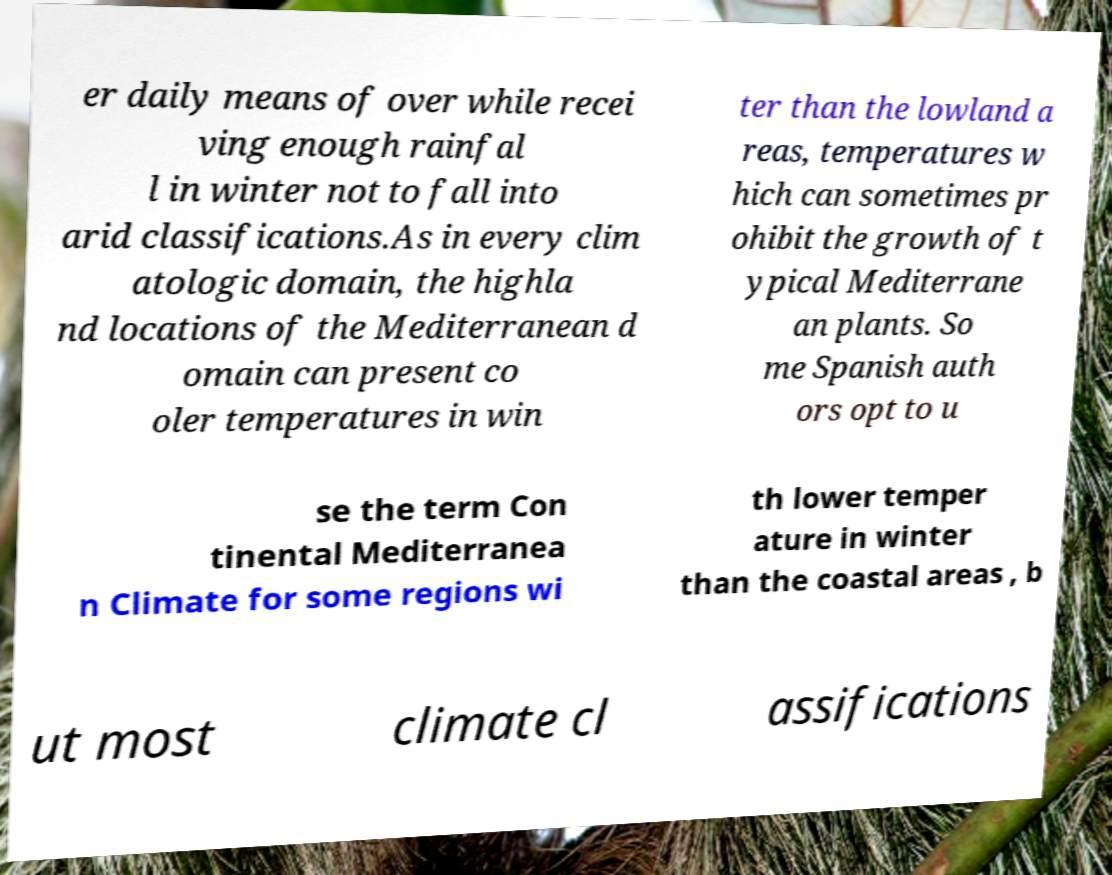There's text embedded in this image that I need extracted. Can you transcribe it verbatim? er daily means of over while recei ving enough rainfal l in winter not to fall into arid classifications.As in every clim atologic domain, the highla nd locations of the Mediterranean d omain can present co oler temperatures in win ter than the lowland a reas, temperatures w hich can sometimes pr ohibit the growth of t ypical Mediterrane an plants. So me Spanish auth ors opt to u se the term Con tinental Mediterranea n Climate for some regions wi th lower temper ature in winter than the coastal areas , b ut most climate cl assifications 